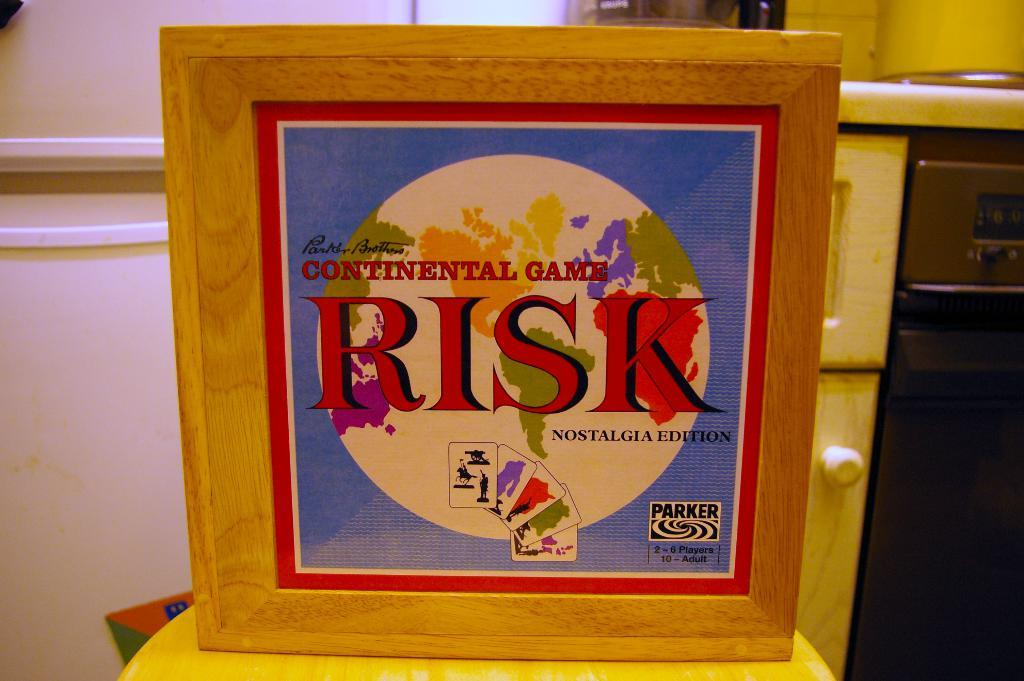<image>
Render a clear and concise summary of the photo. The box contains the nostalgia edition of the game Risk. 